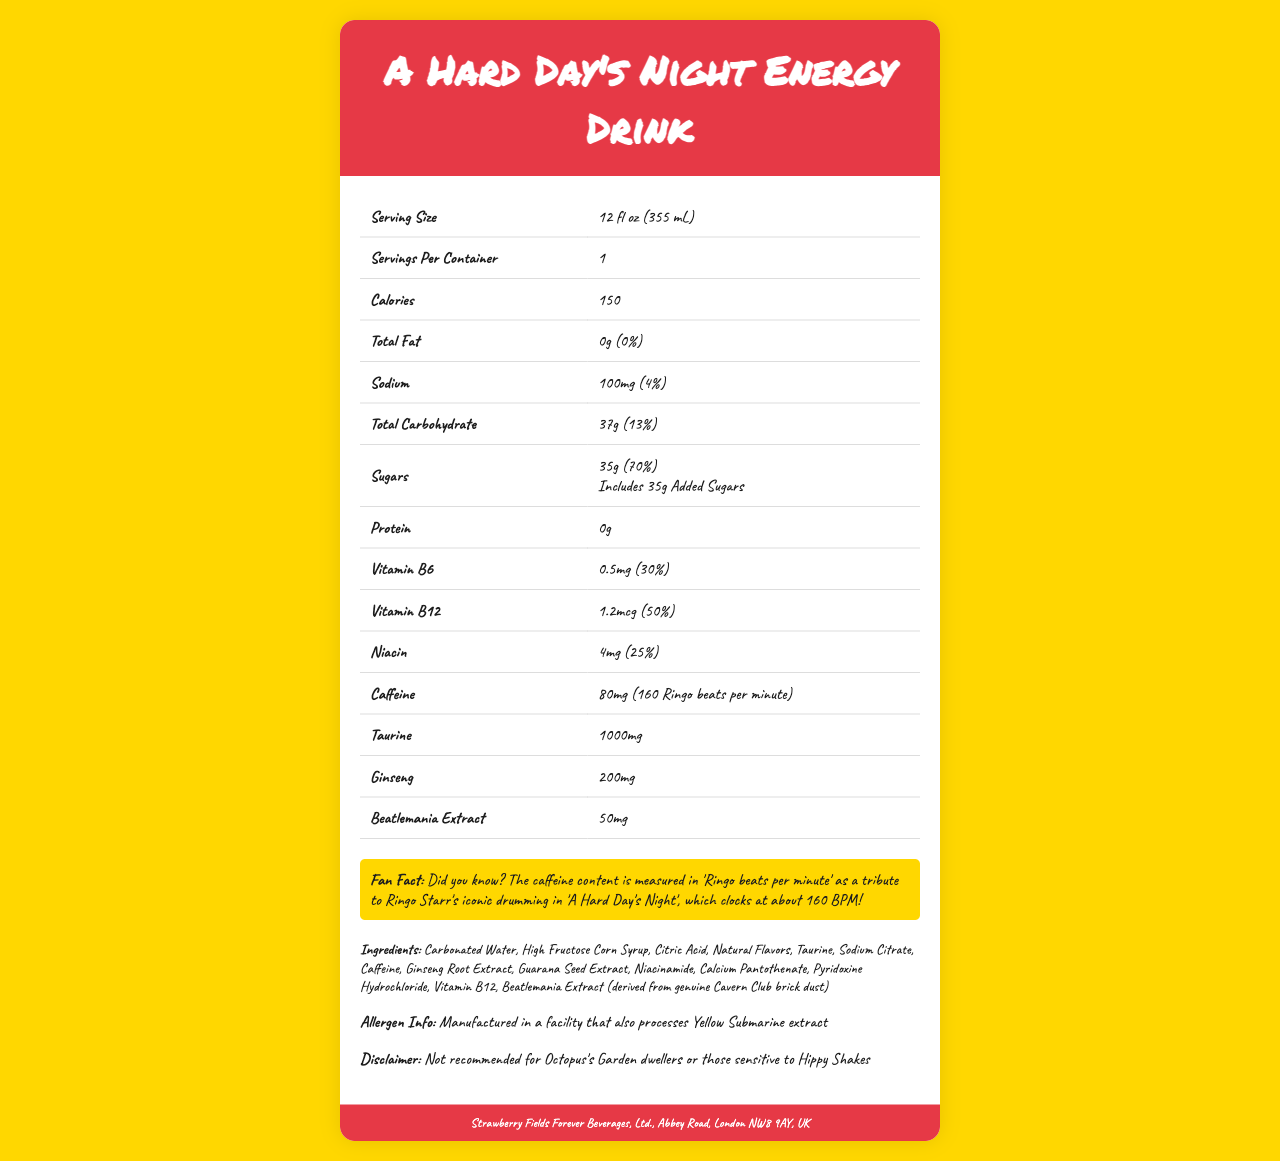what is the serving size? The serving size is specified as 12 fl oz (355 mL) in the document.
Answer: 12 fl oz (355 mL) how many servings are in a container? The document states that there is 1 serving per container.
Answer: 1 how many calories are in a serving? The calories per serving mentioned in the document is 150.
Answer: 150 what is the amount of caffeine in "A Hard Day's Night" energy drink? The document specifies that the caffeine content is 80mg.
Answer: 80mg how much of the daily value percentage does vitamin B12 cover? The document states that vitamin B12 covers 50% of the daily value.
Answer: 50% how much sodium is in the energy drink? The sodium content mentioned is 100mg.
Answer: 100mg which nutrient has the highest daily value percentage? A. Vitamin B6 B. Niacin C. Sugars D. Sodium Sugars have the highest daily value percentage at 70%, according to the document.
Answer: C. Sugars what is the source of inspiration for measuring caffeine in “Ringo beats per minute”? A. John Lennon’s vocal range B. Ringo Starr’s drumming C. Paul McCartney's bassline D. George Harrison’s guitar solos The document mentions the caffeine is measured in "Ringo beats per minute" as a tribute to Ringo Starr's iconic drumming.
Answer: B. Ringo Starr’s drumming is there any protein in "A Hard Day's Night" energy drink? The document lists the protein content as 0g, indicating no protein.
Answer: No does the energy drink contain any added sugars? The document indicates that the 35g of sugars includes 35g of added sugars.
Answer: Yes summarize the main details of the document. The document is a comprehensive Nutrition Facts Label for a specialized energy drink inspired by The Beatles, offering insights into its nutritional contents, ingredients, and some unique attributes related to the band's legacy.
Answer: The document is a Nutrition Facts Label for "A Hard Day's Night Energy Drink." It provides detailed nutritional information, including serving size, calories, total fat, sodium, carbohydrates, sugars, protein, vitamins, and other ingredients. It also features a unique caffeine content measurement in "Ringo beats per minute" and includes a fun fan fact about the caffeine content tribute to Ringo Starr. Additionally, allergen information, a disclaimer, and manufacturer details are provided. what type of facility manufactures the energy drink? The document mentions that it is manufactured in a facility that also processes Yellow Submarine extract, but it does not specify the type of facility.
Answer: Not enough information 